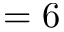<formula> <loc_0><loc_0><loc_500><loc_500>= 6</formula> 